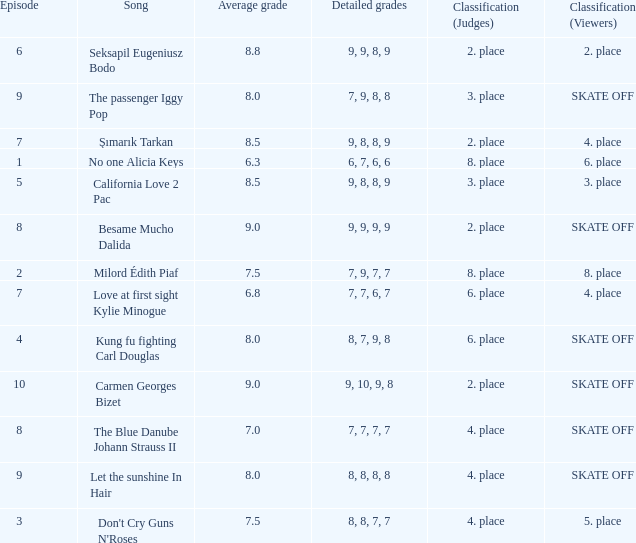Name the classification for 9, 9, 8, 9 2. place. Can you parse all the data within this table? {'header': ['Episode', 'Song', 'Average grade', 'Detailed grades', 'Classification (Judges)', 'Classification (Viewers)'], 'rows': [['6', 'Seksapil Eugeniusz Bodo', '8.8', '9, 9, 8, 9', '2. place', '2. place'], ['9', 'The passenger Iggy Pop', '8.0', '7, 9, 8, 8', '3. place', 'SKATE OFF'], ['7', 'Şımarık Tarkan', '8.5', '9, 8, 8, 9', '2. place', '4. place'], ['1', 'No one Alicia Keys', '6.3', '6, 7, 6, 6', '8. place', '6. place'], ['5', 'California Love 2 Pac', '8.5', '9, 8, 8, 9', '3. place', '3. place'], ['8', 'Besame Mucho Dalida', '9.0', '9, 9, 9, 9', '2. place', 'SKATE OFF'], ['2', 'Milord Édith Piaf', '7.5', '7, 9, 7, 7', '8. place', '8. place'], ['7', 'Love at first sight Kylie Minogue', '6.8', '7, 7, 6, 7', '6. place', '4. place'], ['4', 'Kung fu fighting Carl Douglas', '8.0', '8, 7, 9, 8', '6. place', 'SKATE OFF'], ['10', 'Carmen Georges Bizet', '9.0', '9, 10, 9, 8', '2. place', 'SKATE OFF'], ['8', 'The Blue Danube Johann Strauss II', '7.0', '7, 7, 7, 7', '4. place', 'SKATE OFF'], ['9', 'Let the sunshine In Hair', '8.0', '8, 8, 8, 8', '4. place', 'SKATE OFF'], ['3', "Don't Cry Guns N'Roses", '7.5', '8, 8, 7, 7', '4. place', '5. place']]} 